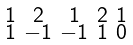Convert formula to latex. <formula><loc_0><loc_0><loc_500><loc_500>\begin{smallmatrix} 1 & 2 & 1 & 2 & 1 \\ 1 & - 1 & - 1 & 1 & 0 \end{smallmatrix}</formula> 